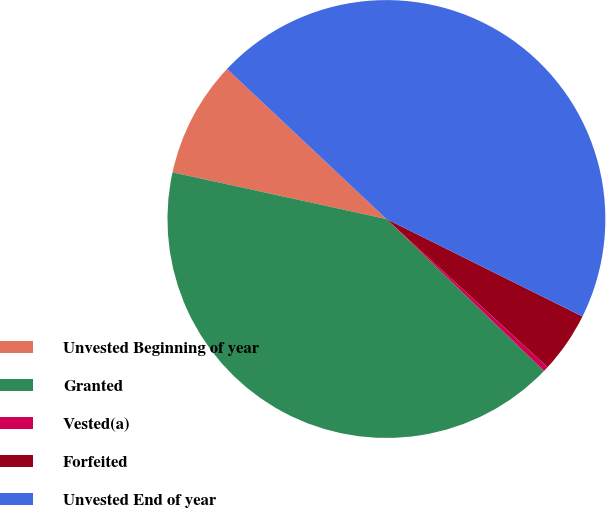Convert chart. <chart><loc_0><loc_0><loc_500><loc_500><pie_chart><fcel>Unvested Beginning of year<fcel>Granted<fcel>Vested(a)<fcel>Forfeited<fcel>Unvested End of year<nl><fcel>8.6%<fcel>41.21%<fcel>0.38%<fcel>4.49%<fcel>45.32%<nl></chart> 